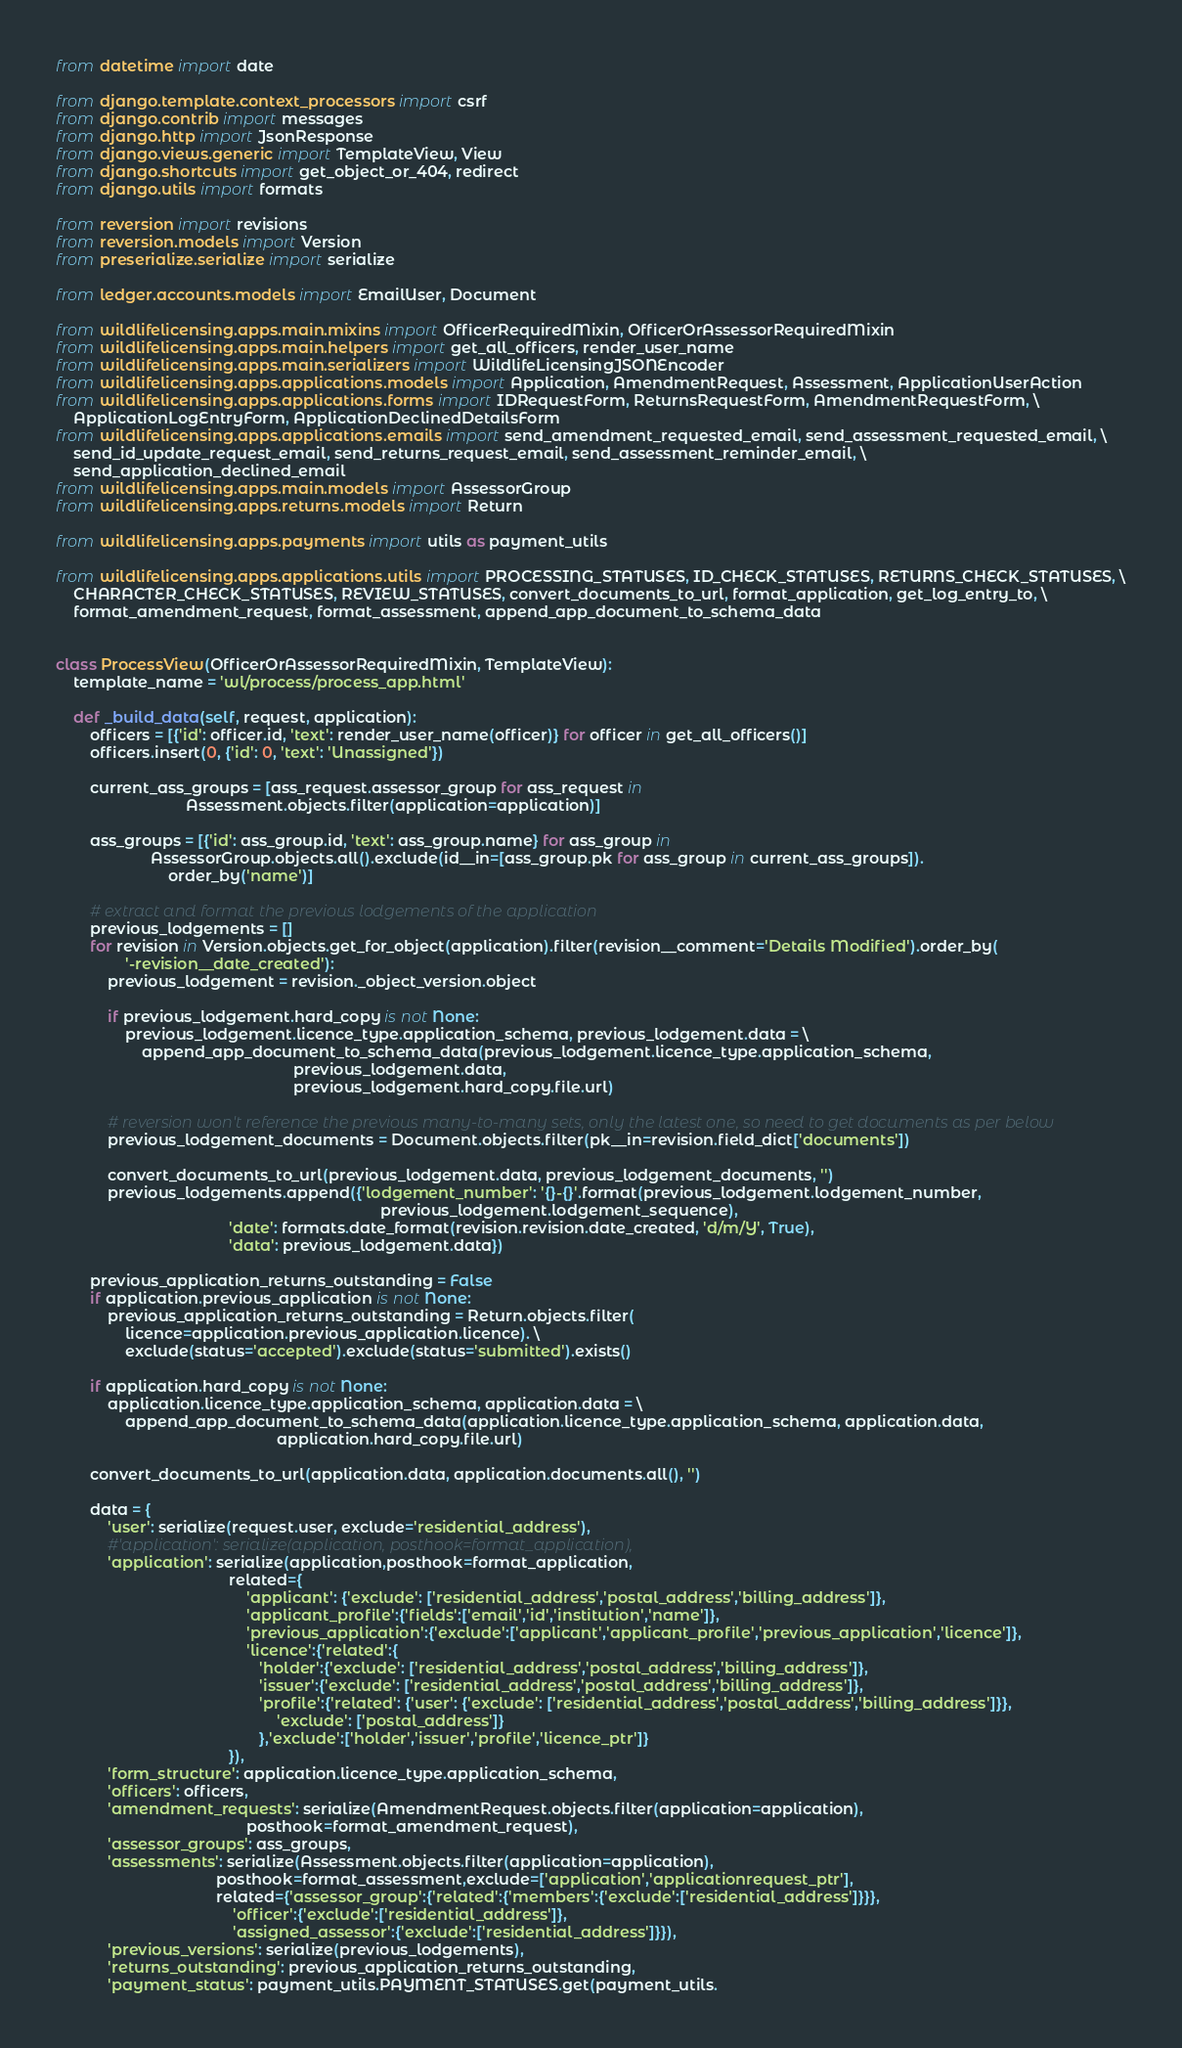<code> <loc_0><loc_0><loc_500><loc_500><_Python_>from datetime import date

from django.template.context_processors import csrf
from django.contrib import messages
from django.http import JsonResponse
from django.views.generic import TemplateView, View
from django.shortcuts import get_object_or_404, redirect
from django.utils import formats

from reversion import revisions
from reversion.models import Version
from preserialize.serialize import serialize

from ledger.accounts.models import EmailUser, Document

from wildlifelicensing.apps.main.mixins import OfficerRequiredMixin, OfficerOrAssessorRequiredMixin
from wildlifelicensing.apps.main.helpers import get_all_officers, render_user_name
from wildlifelicensing.apps.main.serializers import WildlifeLicensingJSONEncoder
from wildlifelicensing.apps.applications.models import Application, AmendmentRequest, Assessment, ApplicationUserAction
from wildlifelicensing.apps.applications.forms import IDRequestForm, ReturnsRequestForm, AmendmentRequestForm, \
    ApplicationLogEntryForm, ApplicationDeclinedDetailsForm
from wildlifelicensing.apps.applications.emails import send_amendment_requested_email, send_assessment_requested_email, \
    send_id_update_request_email, send_returns_request_email, send_assessment_reminder_email, \
    send_application_declined_email
from wildlifelicensing.apps.main.models import AssessorGroup
from wildlifelicensing.apps.returns.models import Return

from wildlifelicensing.apps.payments import utils as payment_utils

from wildlifelicensing.apps.applications.utils import PROCESSING_STATUSES, ID_CHECK_STATUSES, RETURNS_CHECK_STATUSES, \
    CHARACTER_CHECK_STATUSES, REVIEW_STATUSES, convert_documents_to_url, format_application, get_log_entry_to, \
    format_amendment_request, format_assessment, append_app_document_to_schema_data


class ProcessView(OfficerOrAssessorRequiredMixin, TemplateView):
    template_name = 'wl/process/process_app.html'

    def _build_data(self, request, application):
        officers = [{'id': officer.id, 'text': render_user_name(officer)} for officer in get_all_officers()]
        officers.insert(0, {'id': 0, 'text': 'Unassigned'})

        current_ass_groups = [ass_request.assessor_group for ass_request in
                              Assessment.objects.filter(application=application)]

        ass_groups = [{'id': ass_group.id, 'text': ass_group.name} for ass_group in
                      AssessorGroup.objects.all().exclude(id__in=[ass_group.pk for ass_group in current_ass_groups]).
                          order_by('name')]

        # extract and format the previous lodgements of the application
        previous_lodgements = []
        for revision in Version.objects.get_for_object(application).filter(revision__comment='Details Modified').order_by(
                '-revision__date_created'):
            previous_lodgement = revision._object_version.object

            if previous_lodgement.hard_copy is not None:
                previous_lodgement.licence_type.application_schema, previous_lodgement.data = \
                    append_app_document_to_schema_data(previous_lodgement.licence_type.application_schema,
                                                       previous_lodgement.data,
                                                       previous_lodgement.hard_copy.file.url)

            # reversion won't reference the previous many-to-many sets, only the latest one, so need to get documents as per below
            previous_lodgement_documents = Document.objects.filter(pk__in=revision.field_dict['documents'])

            convert_documents_to_url(previous_lodgement.data, previous_lodgement_documents, '')
            previous_lodgements.append({'lodgement_number': '{}-{}'.format(previous_lodgement.lodgement_number,
                                                                           previous_lodgement.lodgement_sequence),
                                        'date': formats.date_format(revision.revision.date_created, 'd/m/Y', True),
                                        'data': previous_lodgement.data})

        previous_application_returns_outstanding = False
        if application.previous_application is not None:
            previous_application_returns_outstanding = Return.objects.filter(
                licence=application.previous_application.licence). \
                exclude(status='accepted').exclude(status='submitted').exists()

        if application.hard_copy is not None:
            application.licence_type.application_schema, application.data = \
                append_app_document_to_schema_data(application.licence_type.application_schema, application.data,
                                                   application.hard_copy.file.url)

        convert_documents_to_url(application.data, application.documents.all(), '')

        data = {
            'user': serialize(request.user, exclude='residential_address'),
            #'application': serialize(application, posthook=format_application),
            'application': serialize(application,posthook=format_application,
                                        related={
                                            'applicant': {'exclude': ['residential_address','postal_address','billing_address']},
                                            'applicant_profile':{'fields':['email','id','institution','name']},
                                            'previous_application':{'exclude':['applicant','applicant_profile','previous_application','licence']},
                                            'licence':{'related':{
                                               'holder':{'exclude': ['residential_address','postal_address','billing_address']},
                                               'issuer':{'exclude': ['residential_address','postal_address','billing_address']},
                                               'profile':{'related': {'user': {'exclude': ['residential_address','postal_address','billing_address']}},
                                                   'exclude': ['postal_address']}
                                               },'exclude':['holder','issuer','profile','licence_ptr']}
                                        }),
            'form_structure': application.licence_type.application_schema,
            'officers': officers,
            'amendment_requests': serialize(AmendmentRequest.objects.filter(application=application),
                                            posthook=format_amendment_request),
            'assessor_groups': ass_groups,
            'assessments': serialize(Assessment.objects.filter(application=application),
                                     posthook=format_assessment,exclude=['application','applicationrequest_ptr'],
                                     related={'assessor_group':{'related':{'members':{'exclude':['residential_address']}}},
                                         'officer':{'exclude':['residential_address']},
                                         'assigned_assessor':{'exclude':['residential_address']}}),
            'previous_versions': serialize(previous_lodgements),
            'returns_outstanding': previous_application_returns_outstanding,
            'payment_status': payment_utils.PAYMENT_STATUSES.get(payment_utils.</code> 